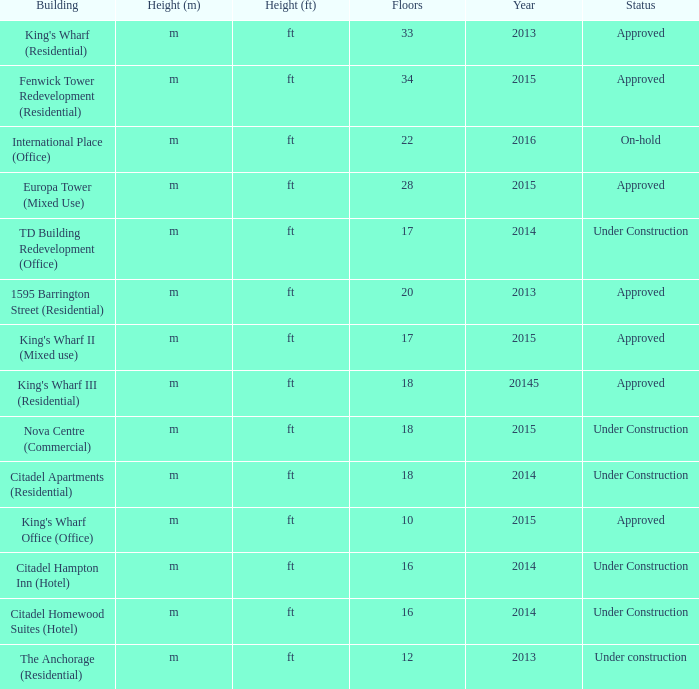What is the state of the construction with in excess of 28 levels and a year of 2013? Approved. Can you parse all the data within this table? {'header': ['Building', 'Height (m)', 'Height (ft)', 'Floors', 'Year', 'Status'], 'rows': [["King's Wharf (Residential)", 'm', 'ft', '33', '2013', 'Approved'], ['Fenwick Tower Redevelopment (Residential)', 'm', 'ft', '34', '2015', 'Approved'], ['International Place (Office)', 'm', 'ft', '22', '2016', 'On-hold'], ['Europa Tower (Mixed Use)', 'm', 'ft', '28', '2015', 'Approved'], ['TD Building Redevelopment (Office)', 'm', 'ft', '17', '2014', 'Under Construction'], ['1595 Barrington Street (Residential)', 'm', 'ft', '20', '2013', 'Approved'], ["King's Wharf II (Mixed use)", 'm', 'ft', '17', '2015', 'Approved'], ["King's Wharf III (Residential)", 'm', 'ft', '18', '20145', 'Approved'], ['Nova Centre (Commercial)', 'm', 'ft', '18', '2015', 'Under Construction'], ['Citadel Apartments (Residential)', 'm', 'ft', '18', '2014', 'Under Construction'], ["King's Wharf Office (Office)", 'm', 'ft', '10', '2015', 'Approved'], ['Citadel Hampton Inn (Hotel)', 'm', 'ft', '16', '2014', 'Under Construction'], ['Citadel Homewood Suites (Hotel)', 'm', 'ft', '16', '2014', 'Under Construction'], ['The Anchorage (Residential)', 'm', 'ft', '12', '2013', 'Under construction']]} 